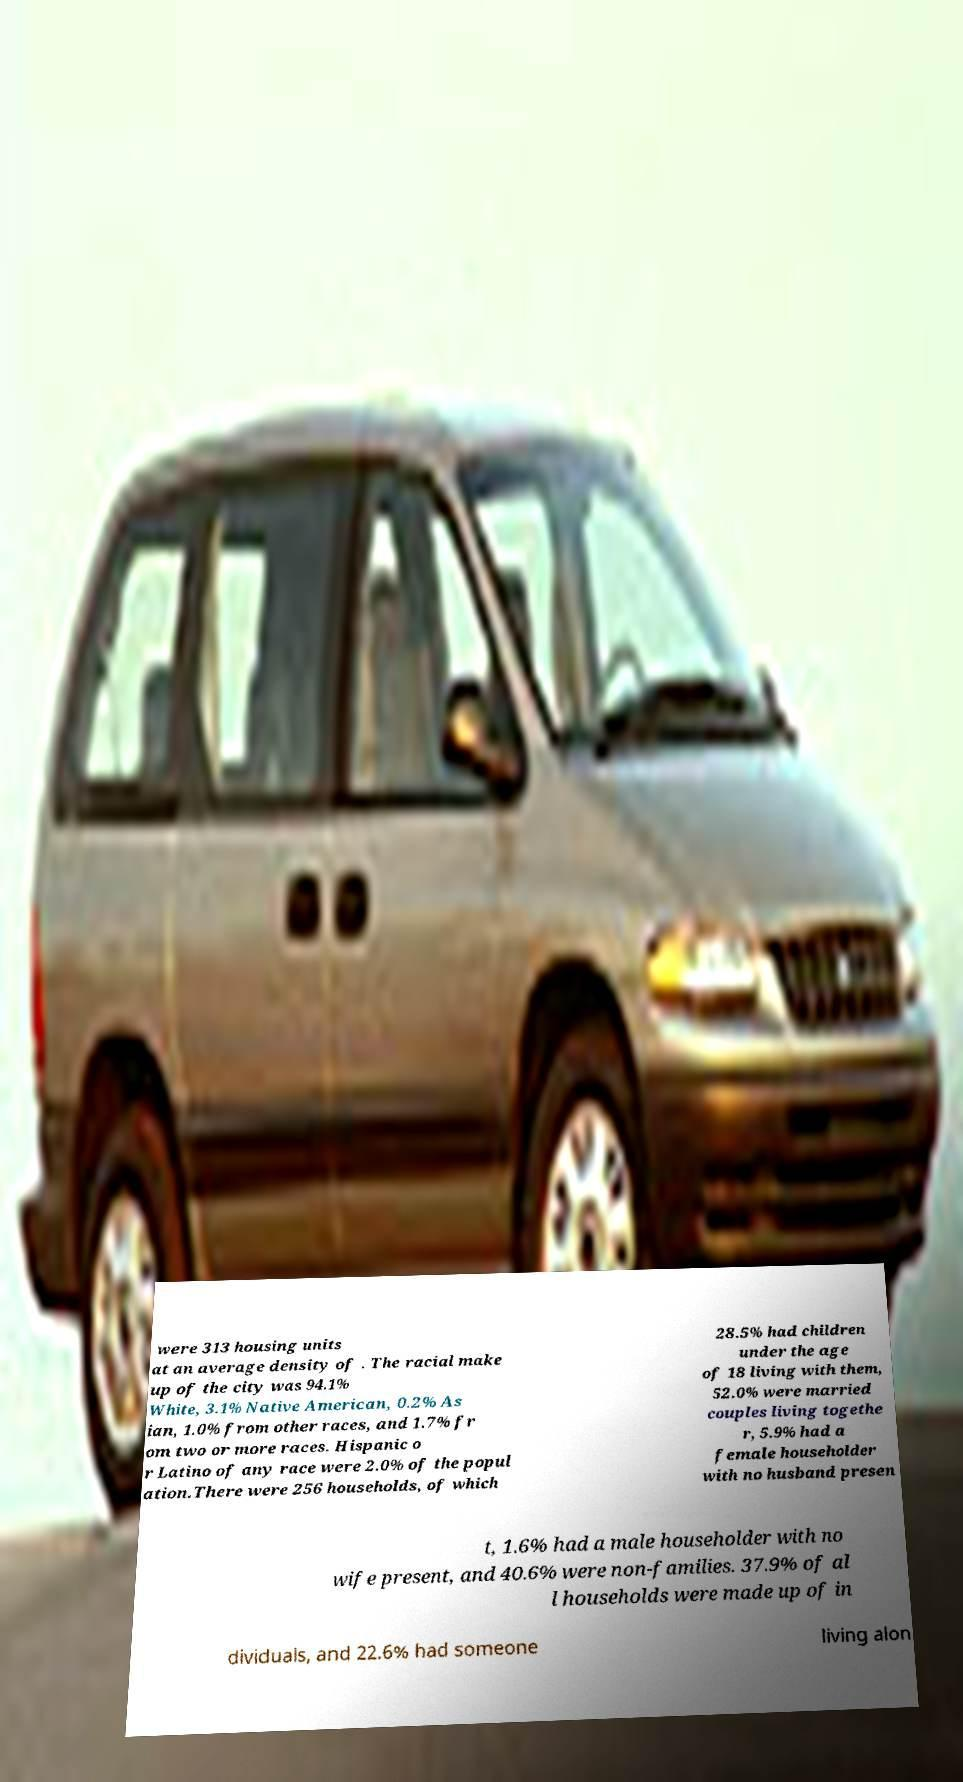Could you assist in decoding the text presented in this image and type it out clearly? were 313 housing units at an average density of . The racial make up of the city was 94.1% White, 3.1% Native American, 0.2% As ian, 1.0% from other races, and 1.7% fr om two or more races. Hispanic o r Latino of any race were 2.0% of the popul ation.There were 256 households, of which 28.5% had children under the age of 18 living with them, 52.0% were married couples living togethe r, 5.9% had a female householder with no husband presen t, 1.6% had a male householder with no wife present, and 40.6% were non-families. 37.9% of al l households were made up of in dividuals, and 22.6% had someone living alon 